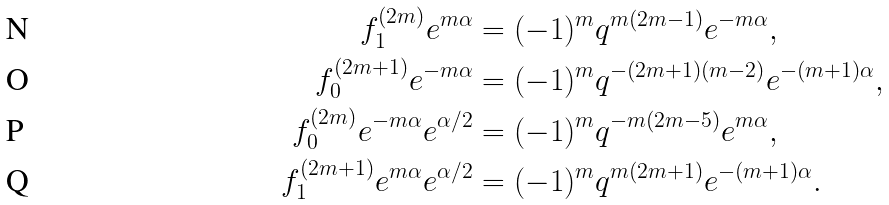Convert formula to latex. <formula><loc_0><loc_0><loc_500><loc_500>f _ { 1 } ^ { ( 2 m ) } e ^ { m \alpha } & = ( - 1 ) ^ { m } q ^ { m ( 2 m - 1 ) } e ^ { - m \alpha } , \\ f _ { 0 } ^ { ( 2 m + 1 ) } e ^ { - m \alpha } & = ( - 1 ) ^ { m } q ^ { - ( 2 m + 1 ) ( m - 2 ) } e ^ { - ( m + 1 ) \alpha } , \\ f _ { 0 } ^ { ( 2 m ) } e ^ { - m \alpha } e ^ { \alpha / 2 } & = ( - 1 ) ^ { m } q ^ { - m ( 2 m - 5 ) } e ^ { m \alpha } , \\ f _ { 1 } ^ { ( 2 m + 1 ) } e ^ { m \alpha } e ^ { \alpha / 2 } & = ( - 1 ) ^ { m } q ^ { m ( 2 m + 1 ) } e ^ { - ( m + 1 ) \alpha } .</formula> 